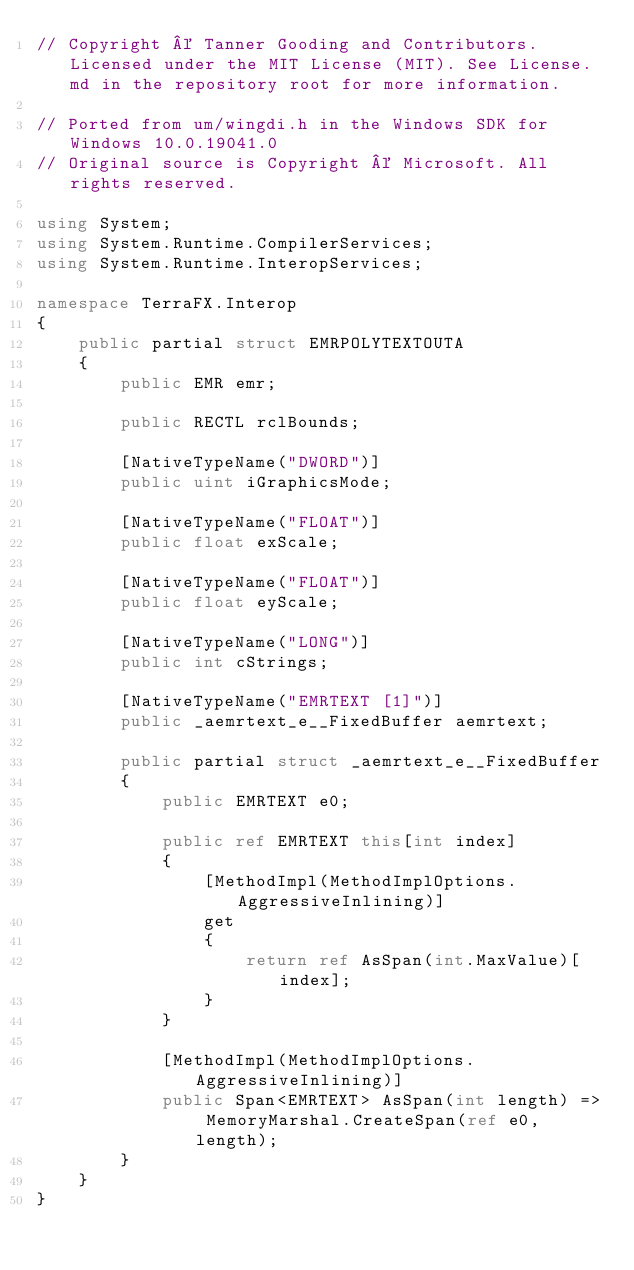<code> <loc_0><loc_0><loc_500><loc_500><_C#_>// Copyright © Tanner Gooding and Contributors. Licensed under the MIT License (MIT). See License.md in the repository root for more information.

// Ported from um/wingdi.h in the Windows SDK for Windows 10.0.19041.0
// Original source is Copyright © Microsoft. All rights reserved.

using System;
using System.Runtime.CompilerServices;
using System.Runtime.InteropServices;

namespace TerraFX.Interop
{
    public partial struct EMRPOLYTEXTOUTA
    {
        public EMR emr;

        public RECTL rclBounds;

        [NativeTypeName("DWORD")]
        public uint iGraphicsMode;

        [NativeTypeName("FLOAT")]
        public float exScale;

        [NativeTypeName("FLOAT")]
        public float eyScale;

        [NativeTypeName("LONG")]
        public int cStrings;

        [NativeTypeName("EMRTEXT [1]")]
        public _aemrtext_e__FixedBuffer aemrtext;

        public partial struct _aemrtext_e__FixedBuffer
        {
            public EMRTEXT e0;

            public ref EMRTEXT this[int index]
            {
                [MethodImpl(MethodImplOptions.AggressiveInlining)]
                get
                {
                    return ref AsSpan(int.MaxValue)[index];
                }
            }

            [MethodImpl(MethodImplOptions.AggressiveInlining)]
            public Span<EMRTEXT> AsSpan(int length) => MemoryMarshal.CreateSpan(ref e0, length);
        }
    }
}
</code> 